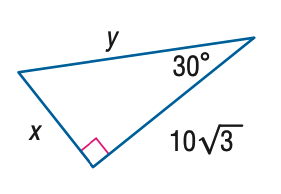Answer the mathemtical geometry problem and directly provide the correct option letter.
Question: Find y.
Choices: A: 10 B: 20 C: 10 \sqrt { 6 } D: 30 B 